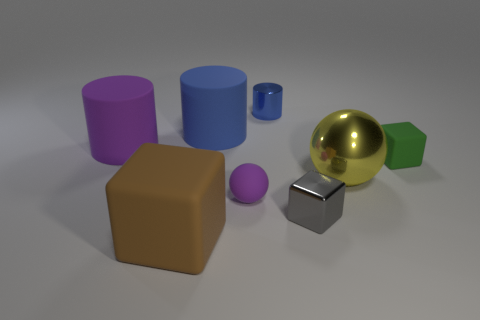Do the metallic sphere and the gray metal object have the same size?
Your response must be concise. No. What number of things are metallic cubes or big rubber spheres?
Provide a succinct answer. 1. What size is the matte block that is right of the yellow metal thing behind the tiny purple object?
Keep it short and to the point. Small. The purple ball is what size?
Ensure brevity in your answer.  Small. What shape is the small object that is behind the large yellow shiny thing and to the left of the green matte cube?
Keep it short and to the point. Cylinder. There is another tiny metal thing that is the same shape as the brown object; what is its color?
Offer a terse response. Gray. What number of things are either small objects on the right side of the small cylinder or small things in front of the small blue cylinder?
Provide a short and direct response. 3. The big purple thing has what shape?
Offer a very short reply. Cylinder. There is a large object that is the same color as the shiny cylinder; what is its shape?
Make the answer very short. Cylinder. What number of other spheres are made of the same material as the big yellow sphere?
Make the answer very short. 0. 